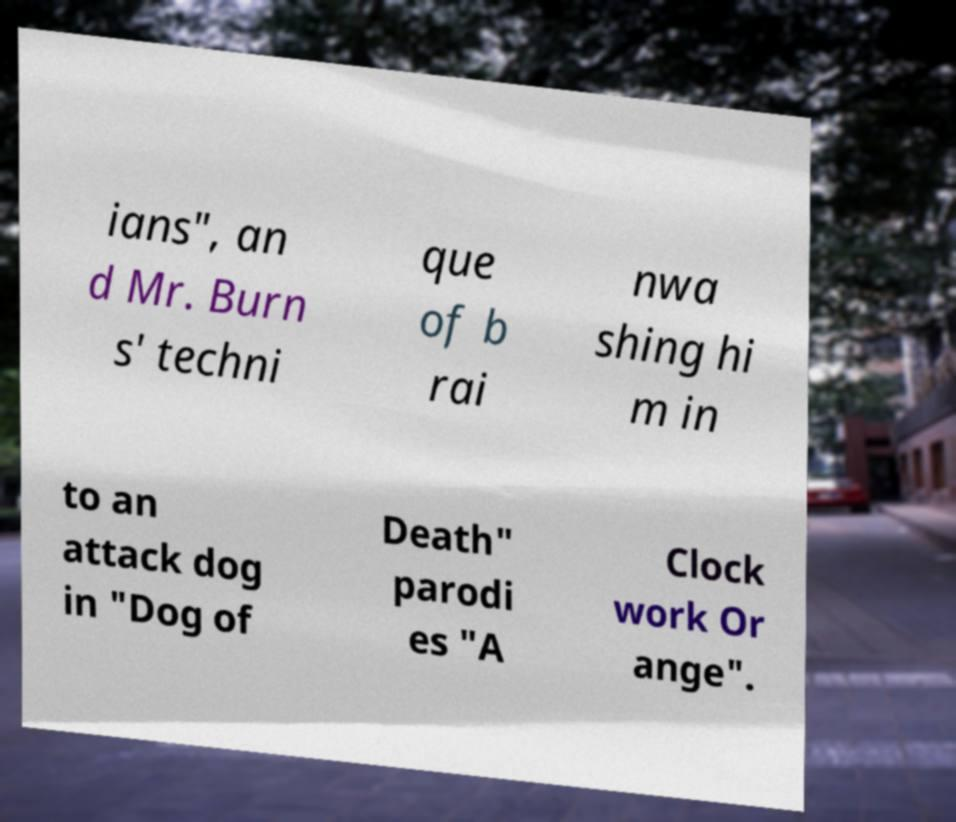There's text embedded in this image that I need extracted. Can you transcribe it verbatim? ians", an d Mr. Burn s' techni que of b rai nwa shing hi m in to an attack dog in "Dog of Death" parodi es "A Clock work Or ange". 